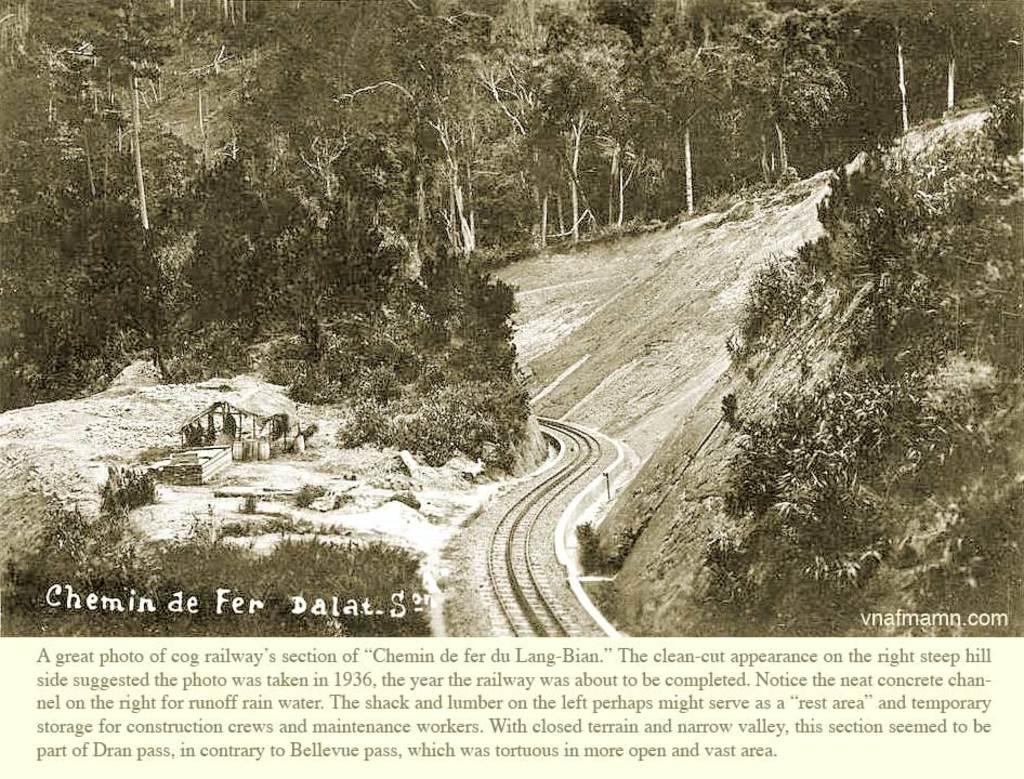What type of vegetation can be seen in the image? There are trees in the image. What type of structure is present in the image? There is a shed in the image. What type of transportation infrastructure is visible in the image? There is a railway-track in the image. What is the weather condition in the image? There is snow in the image. What type of written material is present in the image? There is a paper with writing on it in the image. What type of roof can be seen on the carriage in the image? There is no carriage present in the image; it features trees, a shed, a railway-track, snow, and a paper with writing on it. What type of flesh is visible on the trees in the image? There is no flesh visible on the trees in the image; they are covered in snow. 